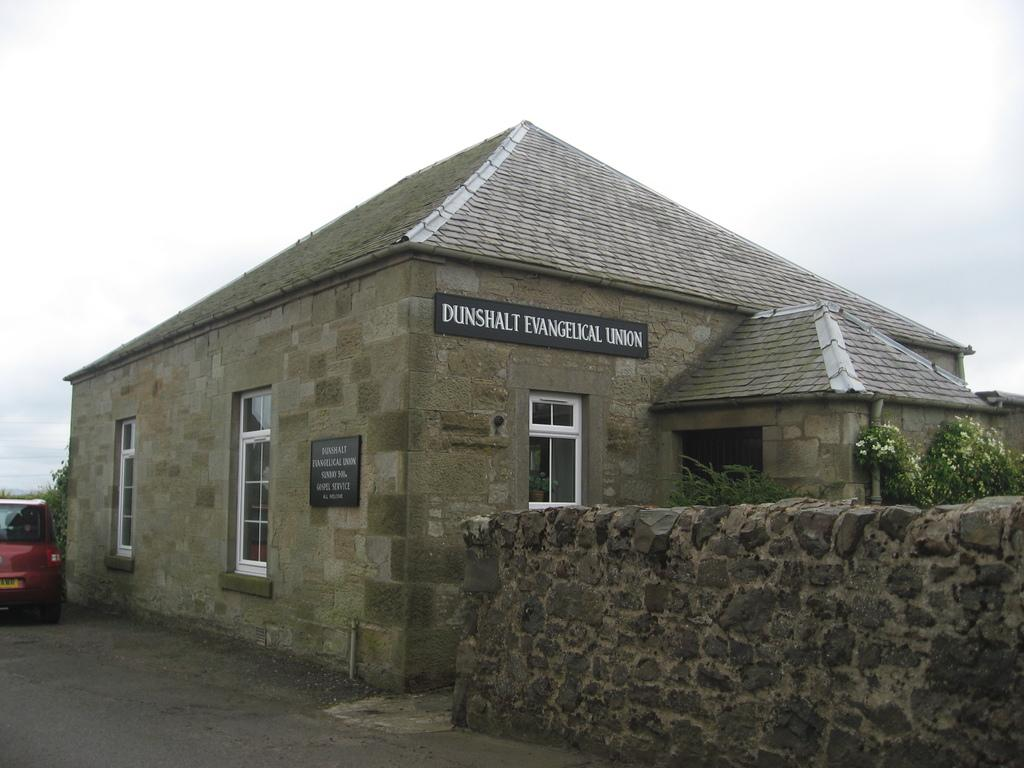What type of structure is visible in the image? There is a house in the image. What mode of transportation can be seen in the image? There is a car in the image. What architectural feature is present in the image? There are windows in the image. What material is used for the boards in the image? The boards in the image are made of a material that is not specified in the facts. What type of vegetation is present in the image? There are plants and flowers in the image. What type of barrier is present in the image? There is a wall in the image. What is visible in the background of the image? The sky is visible in the background of the image. Can you see a quill being used to write on the wall in the image? There is no quill or writing activity present in the image. Is the coast visible in the background of the image? The image does not depict a coast; it shows a house, a car, windows, boards, plants, flowers, a wall, and the sky. 